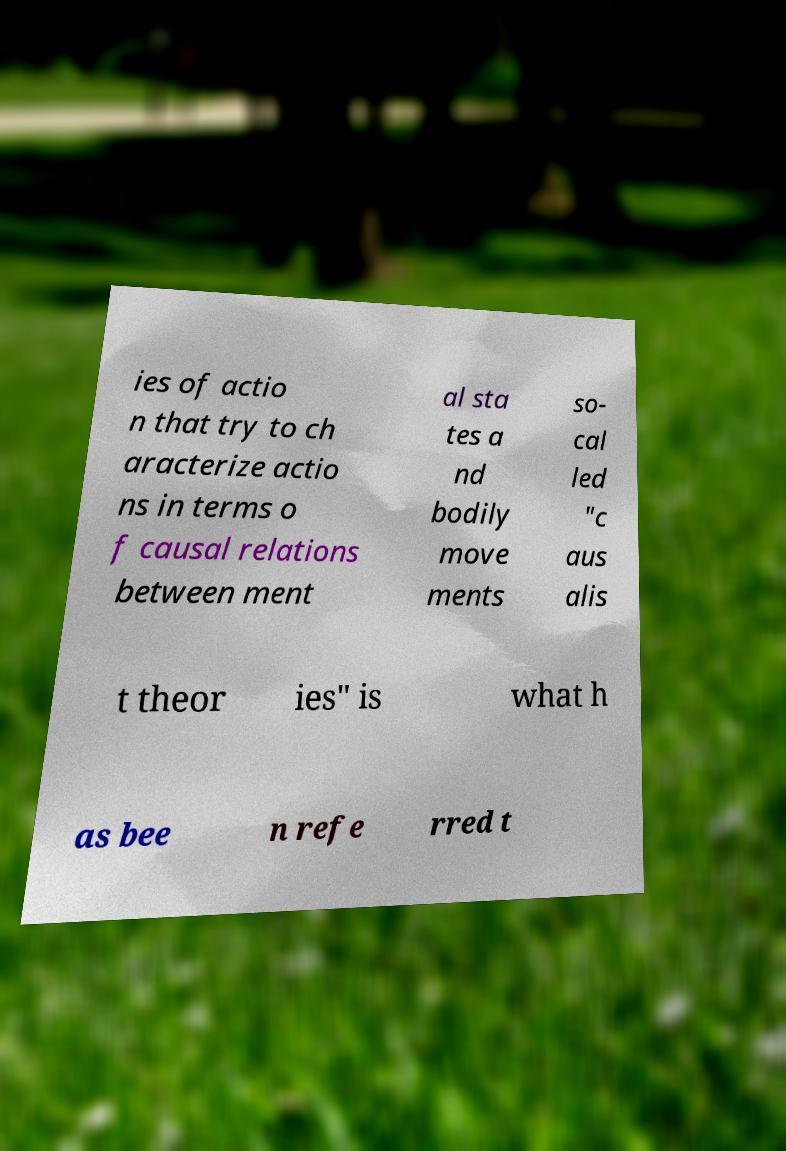Can you read and provide the text displayed in the image?This photo seems to have some interesting text. Can you extract and type it out for me? ies of actio n that try to ch aracterize actio ns in terms o f causal relations between ment al sta tes a nd bodily move ments so- cal led "c aus alis t theor ies" is what h as bee n refe rred t 